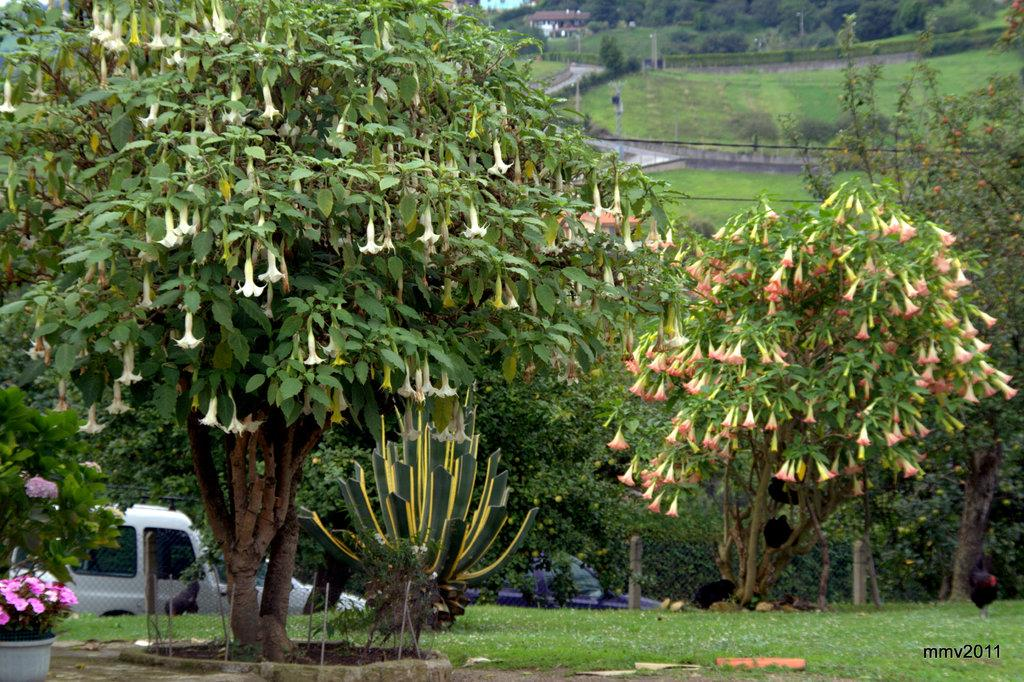What type of vegetation can be seen in the foreground of the image? There is greenery in the foreground of the image. What type of barrier is present in the image? There is a net fencing in the image. What type of man-made object is visible in the image? A vehicle is present in the image. What type of structure can be seen in the background of the image? There is a house structure in the background of the image. What type of natural elements are visible in the background of the image? Trees and grassland are visible in the background of the image. What type of vertical structures are present in the background of the image? Poles are present in the background of the image. What type of sponge is used to clean the vehicle in the image? There is no sponge visible in the image, and the cleaning process of the vehicle is not depicted. What type of thread is used to connect the trees in the background of the image? There is no thread connecting the trees in the image; they are naturally growing apart from each other. 